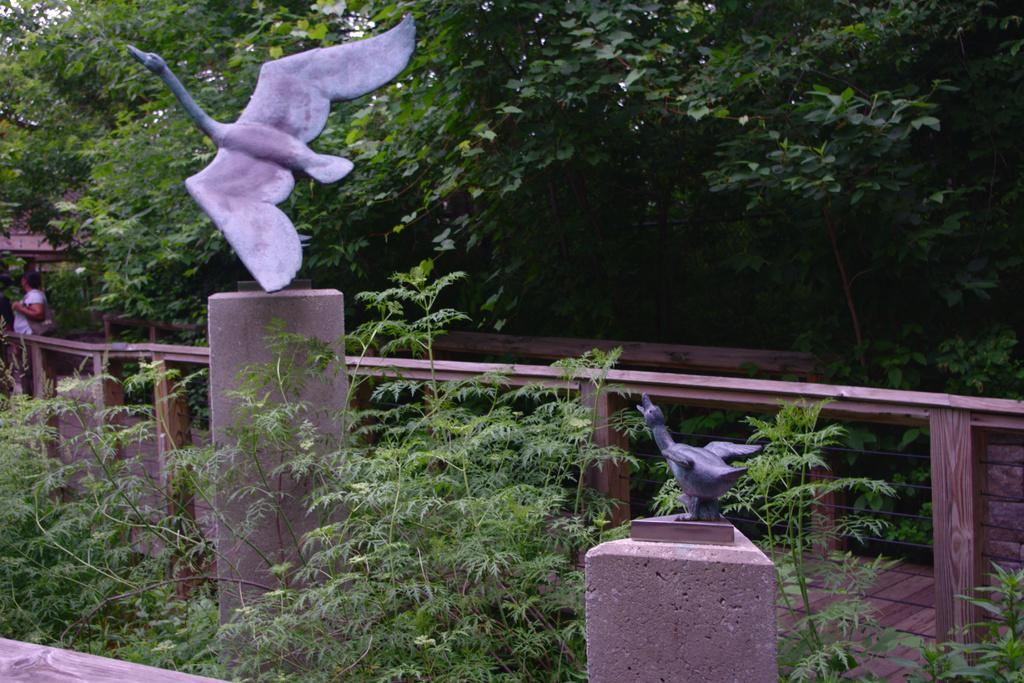What type of living organisms can be seen in the image? Plants and bird statues are visible in the image. What natural element is present in the image? There is a tree in the image. Can you describe the person in the image? There is a person standing in the background of the image. What type of country is depicted in the image? There is no country depicted in the image; it features plants, bird statues, a tree, and a person. Can you describe the sidewalk in the image? There is no sidewalk present in the image. 